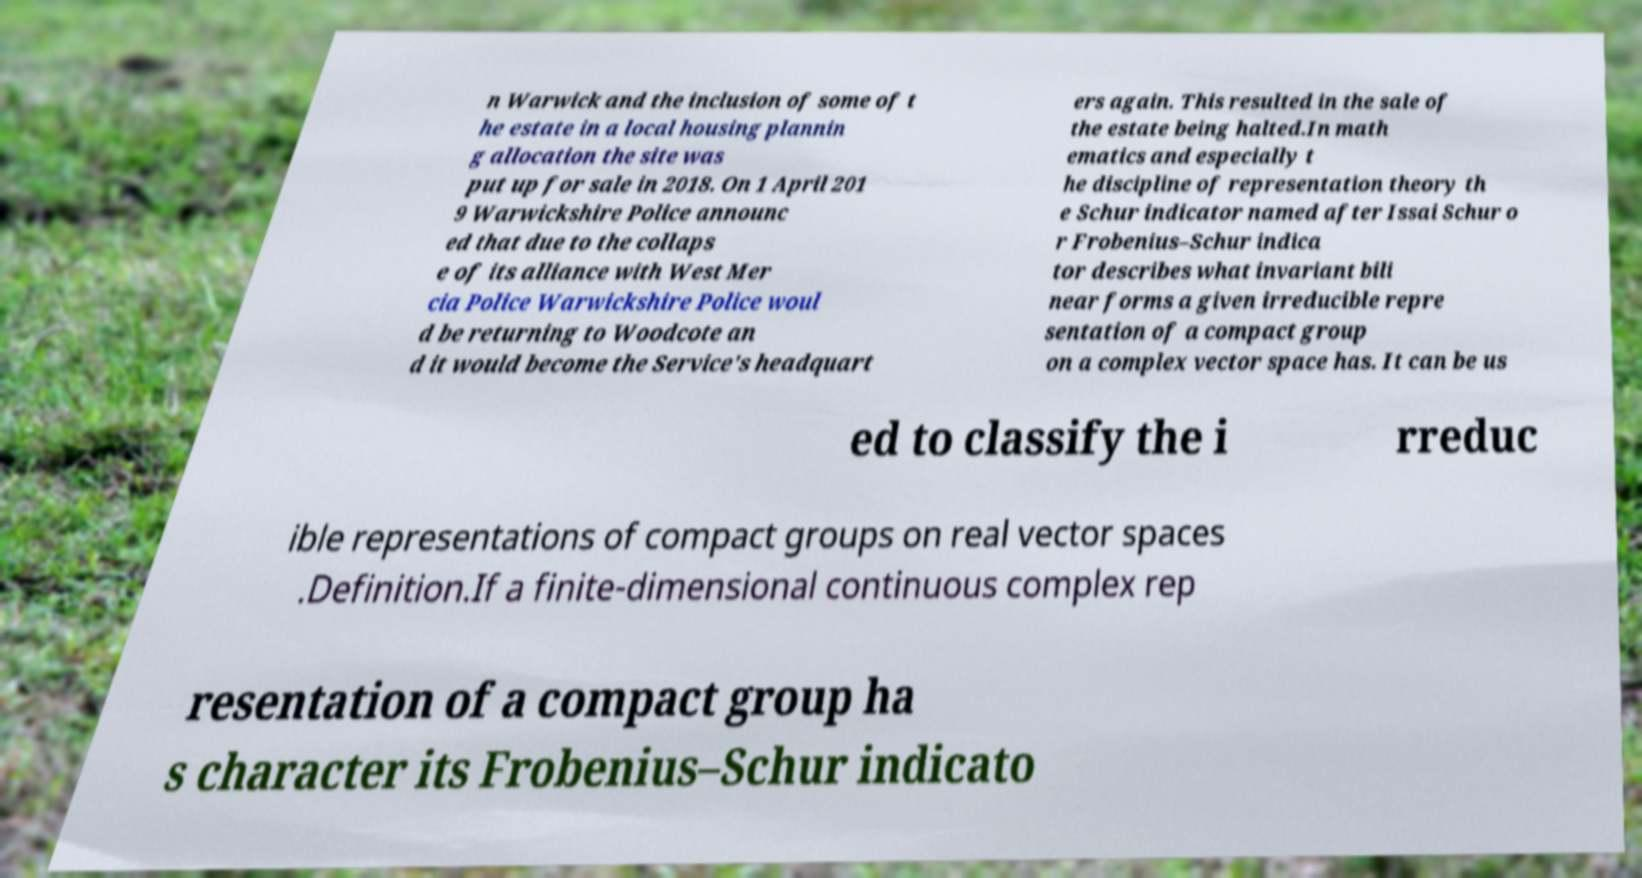Could you extract and type out the text from this image? n Warwick and the inclusion of some of t he estate in a local housing plannin g allocation the site was put up for sale in 2018. On 1 April 201 9 Warwickshire Police announc ed that due to the collaps e of its alliance with West Mer cia Police Warwickshire Police woul d be returning to Woodcote an d it would become the Service's headquart ers again. This resulted in the sale of the estate being halted.In math ematics and especially t he discipline of representation theory th e Schur indicator named after Issai Schur o r Frobenius–Schur indica tor describes what invariant bili near forms a given irreducible repre sentation of a compact group on a complex vector space has. It can be us ed to classify the i rreduc ible representations of compact groups on real vector spaces .Definition.If a finite-dimensional continuous complex rep resentation of a compact group ha s character its Frobenius–Schur indicato 